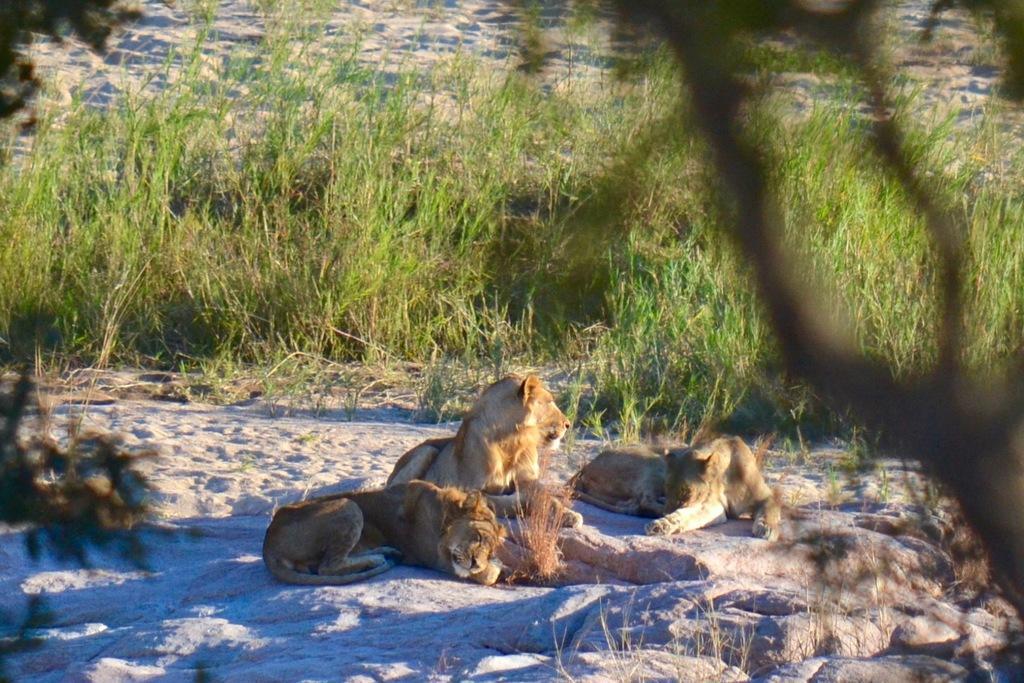Could you give a brief overview of what you see in this image? In this image we can see few animals. We can see the grass in the image. We can see the sand in the image. 